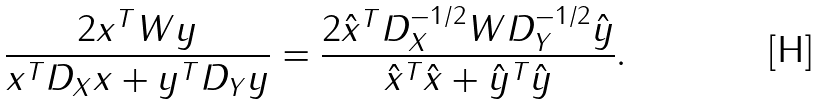<formula> <loc_0><loc_0><loc_500><loc_500>\frac { 2 x ^ { T } W y } { x ^ { T } D _ { X } x + y ^ { T } D _ { Y } y } = \frac { 2 \hat { x } ^ { T } D _ { X } ^ { - 1 / 2 } W D _ { Y } ^ { - 1 / 2 } \hat { y } } { \hat { x } ^ { T } \hat { x } + \hat { y } ^ { T } \hat { y } } .</formula> 